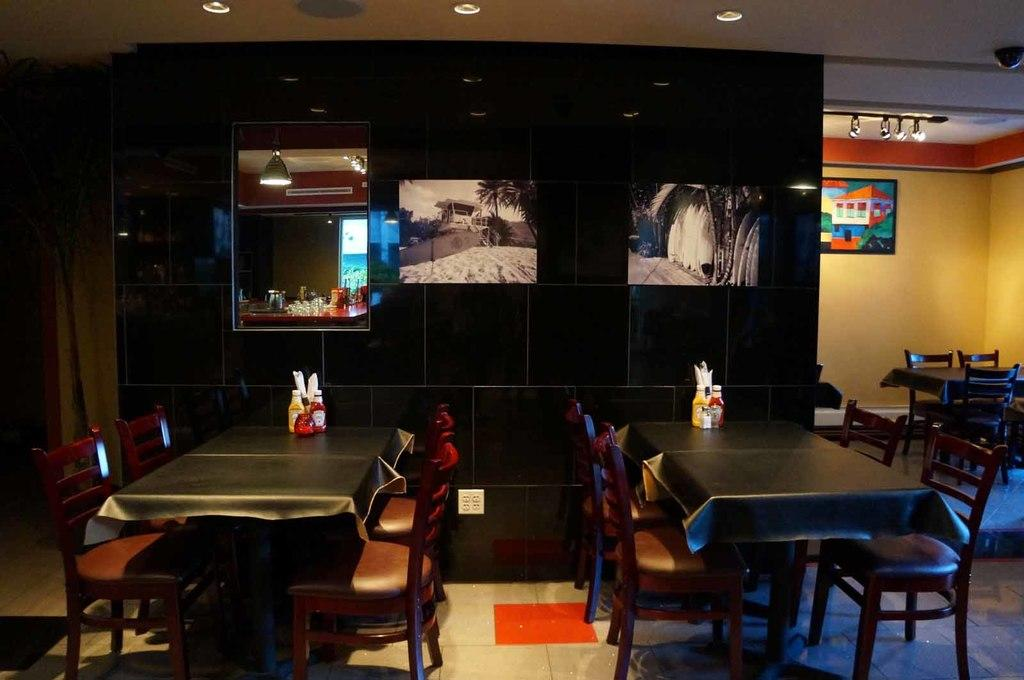What objects can be seen on tables in the image? There are bottles on tables in the image. What type of furniture is on the floor in the image? There are chairs on the floor in the image. What is hanging on the wall in the image? There are frames on the wall in the image. What provides illumination in the image? There are lights in the image. What can be seen in the distance in the image? There are objects visible in the background of the image. How many gloves can be seen in the image? There are no gloves present in the image. What type of polish is being applied to the frames in the image? There is no polish or any indication of polishing activity in the image. 